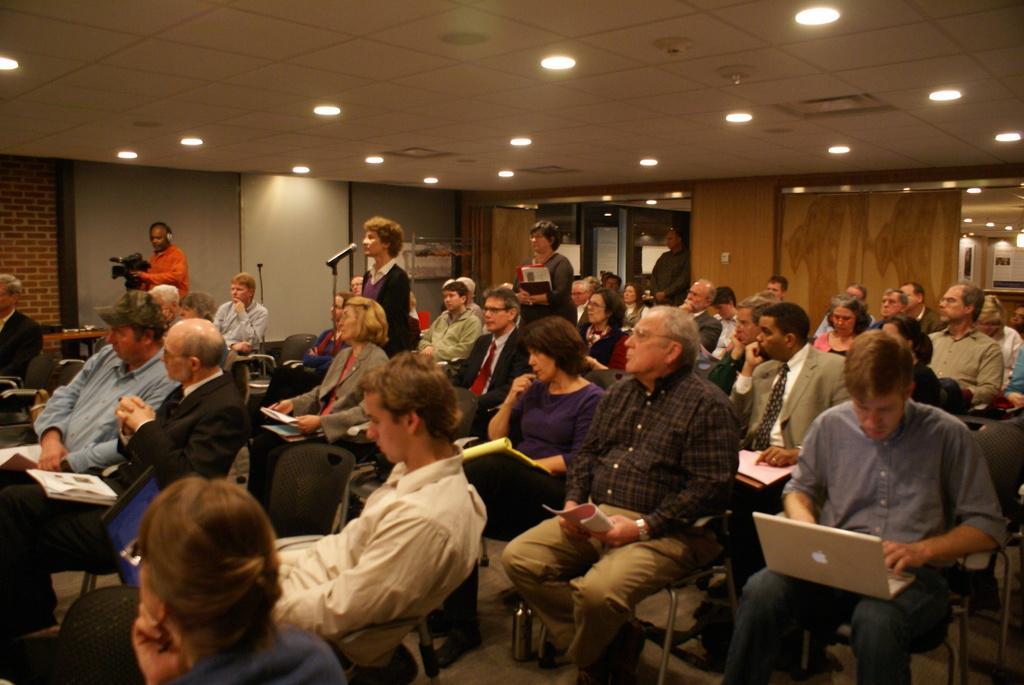In one or two sentences, can you explain what this image depicts? There are group of persons, sitting on chairs, some persons standing. On the right side, there is a person in a shirt, keeping laptop on his lap, and working on it. In the background, there is wall. 